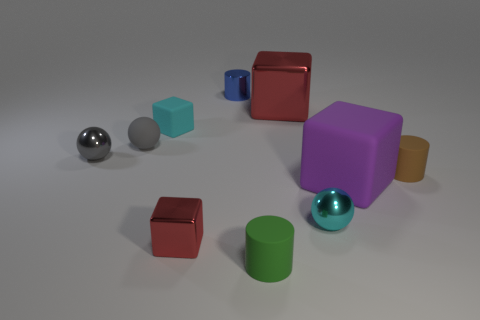Subtract 1 blocks. How many blocks are left? 3 Subtract all blue cubes. Subtract all brown spheres. How many cubes are left? 4 Subtract all cubes. How many objects are left? 6 Subtract 0 brown blocks. How many objects are left? 10 Subtract all small metal cubes. Subtract all small gray shiny things. How many objects are left? 8 Add 6 tiny metal cubes. How many tiny metal cubes are left? 7 Add 3 yellow rubber cylinders. How many yellow rubber cylinders exist? 3 